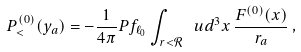Convert formula to latex. <formula><loc_0><loc_0><loc_500><loc_500>P _ { < } ^ { ( 0 ) } ( y _ { a } ) = - \frac { 1 } { 4 \pi } P f _ { \ell _ { 0 } } \int _ { r < \mathcal { R } } \ u d ^ { 3 } { x } \, \frac { F ^ { ( 0 ) } ( { x } ) } { r _ { a } } \, ,</formula> 